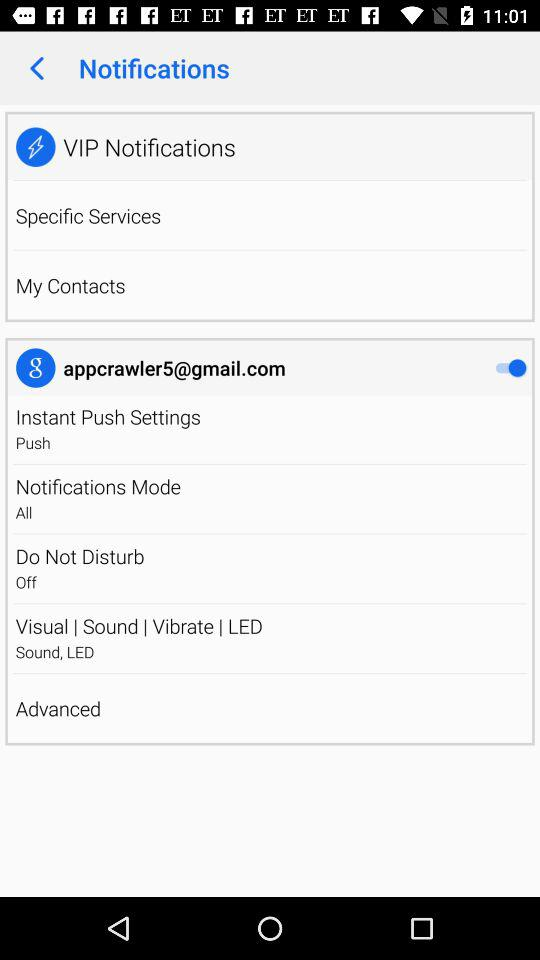What is the status of "Notifications Mode"? The status is "All". 